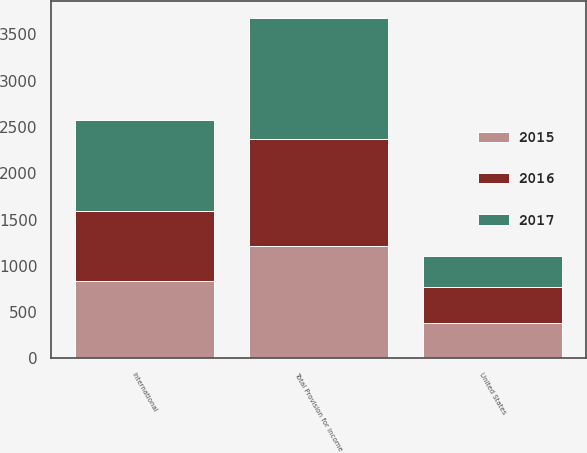Convert chart to OTSL. <chart><loc_0><loc_0><loc_500><loc_500><stacked_bar_chart><ecel><fcel>United States<fcel>International<fcel>Total Provision for income<nl><fcel>2017<fcel>338<fcel>975<fcel>1313<nl><fcel>2016<fcel>395<fcel>757<fcel>1152<nl><fcel>2015<fcel>376<fcel>839<fcel>1215<nl></chart> 